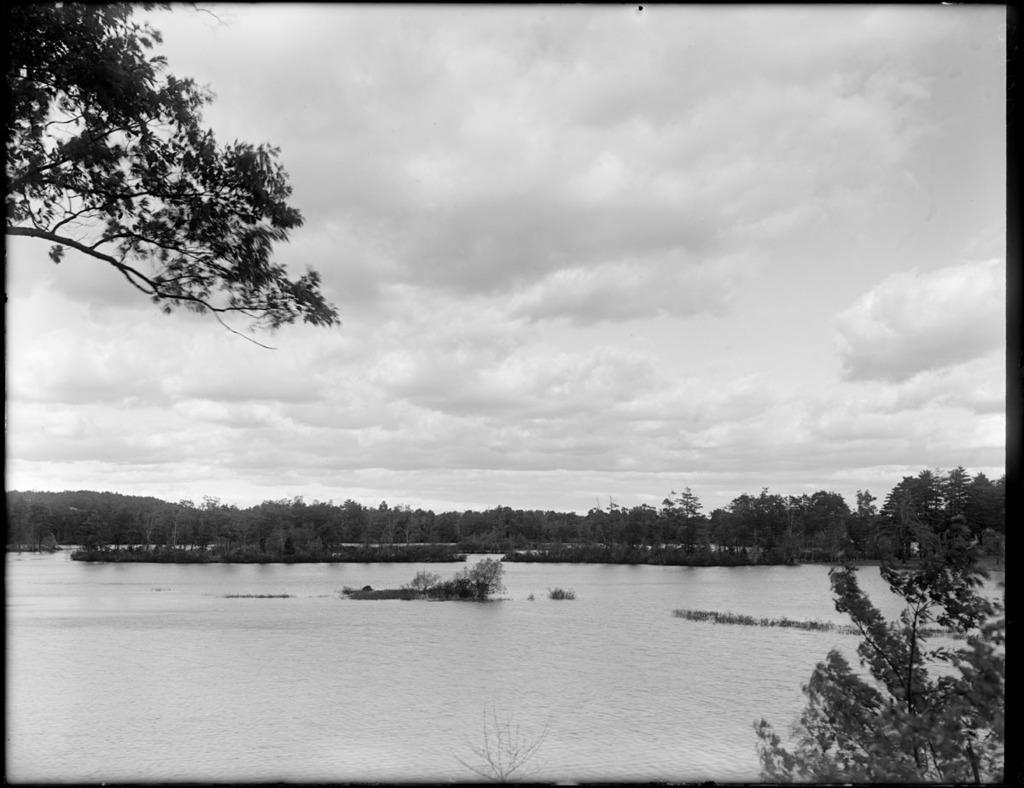Describe this image in one or two sentences. In the picture I can see water and there are trees in the background. 